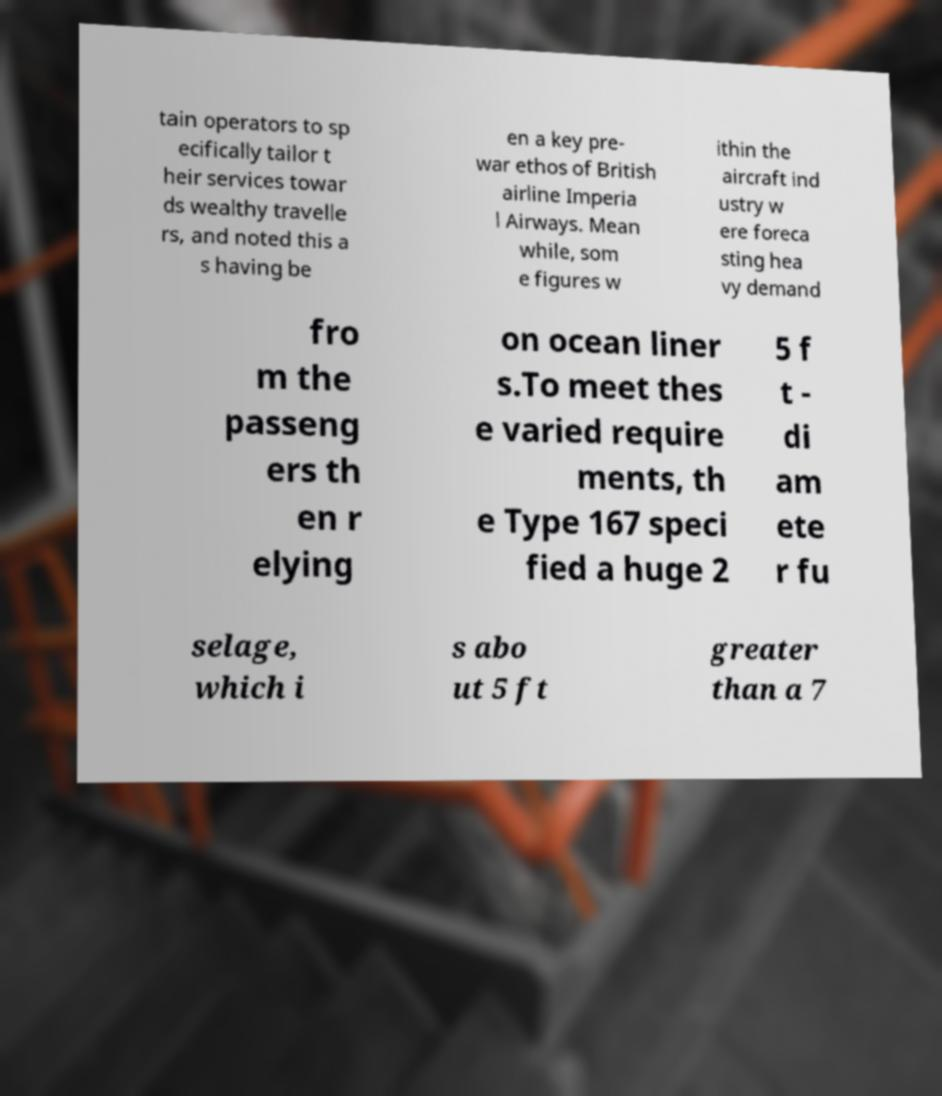For documentation purposes, I need the text within this image transcribed. Could you provide that? tain operators to sp ecifically tailor t heir services towar ds wealthy travelle rs, and noted this a s having be en a key pre- war ethos of British airline Imperia l Airways. Mean while, som e figures w ithin the aircraft ind ustry w ere foreca sting hea vy demand fro m the passeng ers th en r elying on ocean liner s.To meet thes e varied require ments, th e Type 167 speci fied a huge 2 5 f t - di am ete r fu selage, which i s abo ut 5 ft greater than a 7 